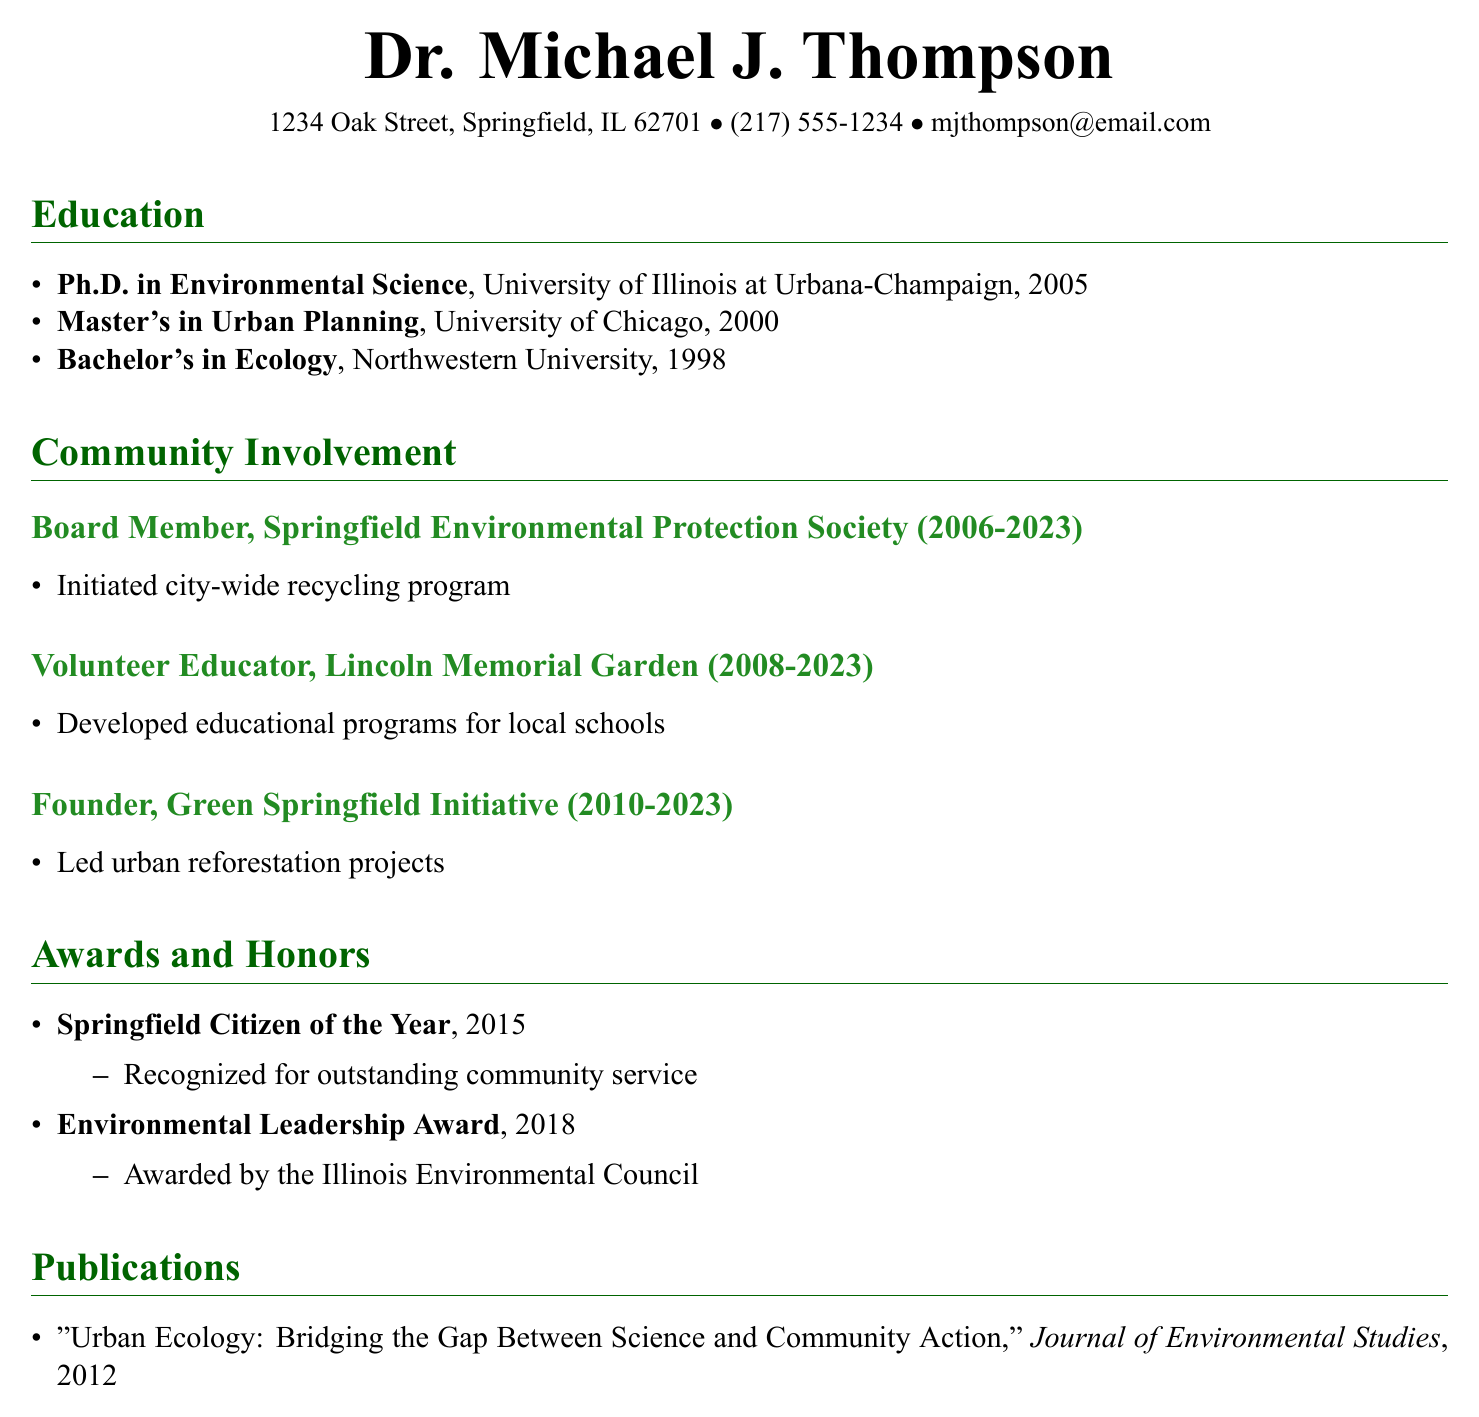What degree did Dr. Michael J. Thompson earn in 2005? The document states that Dr. Michael J. Thompson earned a Ph.D. in Environmental Science in 2005.
Answer: Ph.D. in Environmental Science What organization did Dr. Thompson found in 2010? According to the document, he founded the Green Springfield Initiative in 2010.
Answer: Green Springfield Initiative How many years did Dr. Thompson serve as a board member for the Springfield Environmental Protection Society? The duration of his service as a board member is provided in the document, which is from 2006 to 2023, totaling 17 years.
Answer: 17 years What educational program did Dr. Thompson develop at Lincoln Memorial Garden? The document mentions that he developed educational programs for local schools during his time as a Volunteer Educator.
Answer: Educational programs for local schools What award did Dr. Thompson receive in 2015? The resume lists the Springfield Citizen of the Year award received in 2015.
Answer: Springfield Citizen of the Year Which publication did Dr. Thompson write in 2012? The document indicates that he wrote "Urban Ecology: Bridging the Gap Between Science and Community Action" in 2012.
Answer: Urban Ecology: Bridging the Gap Between Science and Community Action What was the impact of the Green Springfield Initiative? The resume states that the initiative led urban reforestation projects.
Answer: Led urban reforestation projects How many organizations was Dr. Thompson involved with in his community work? The document lists three organizations under community involvement.
Answer: Three organizations 